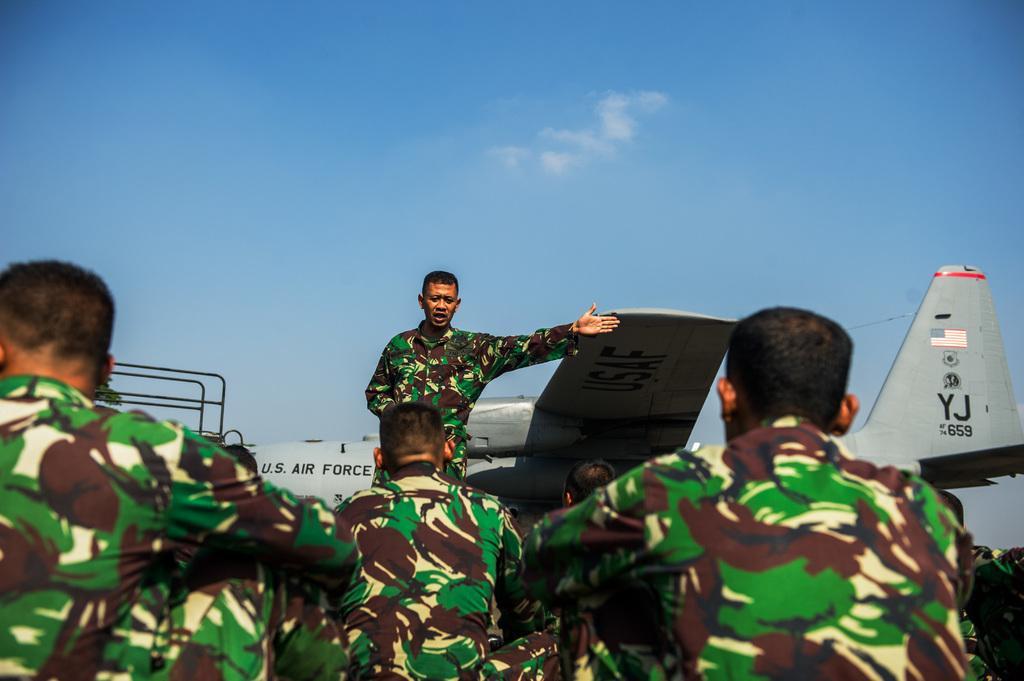How would you summarize this image in a sentence or two? In this picture we can see a group of people and in front of them we can see a man standing, airplane, rods and in the background we can see the sky. 